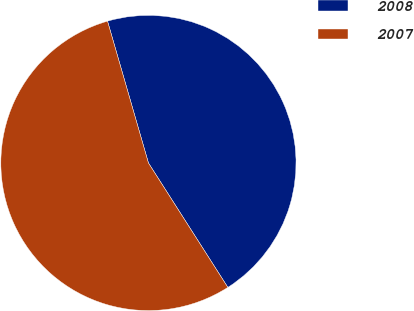Convert chart to OTSL. <chart><loc_0><loc_0><loc_500><loc_500><pie_chart><fcel>2008<fcel>2007<nl><fcel>45.43%<fcel>54.57%<nl></chart> 